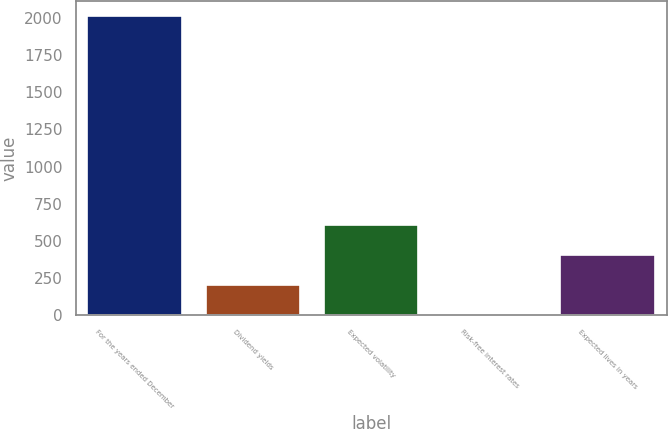Convert chart. <chart><loc_0><loc_0><loc_500><loc_500><bar_chart><fcel>For the years ended December<fcel>Dividend yields<fcel>Expected volatility<fcel>Risk-free interest rates<fcel>Expected lives in years<nl><fcel>2009<fcel>202.79<fcel>604.17<fcel>2.1<fcel>403.48<nl></chart> 